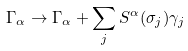<formula> <loc_0><loc_0><loc_500><loc_500>\Gamma _ { \alpha } \rightarrow \Gamma _ { \alpha } + \sum _ { j } S ^ { \alpha } ( \sigma _ { j } ) \gamma _ { j }</formula> 